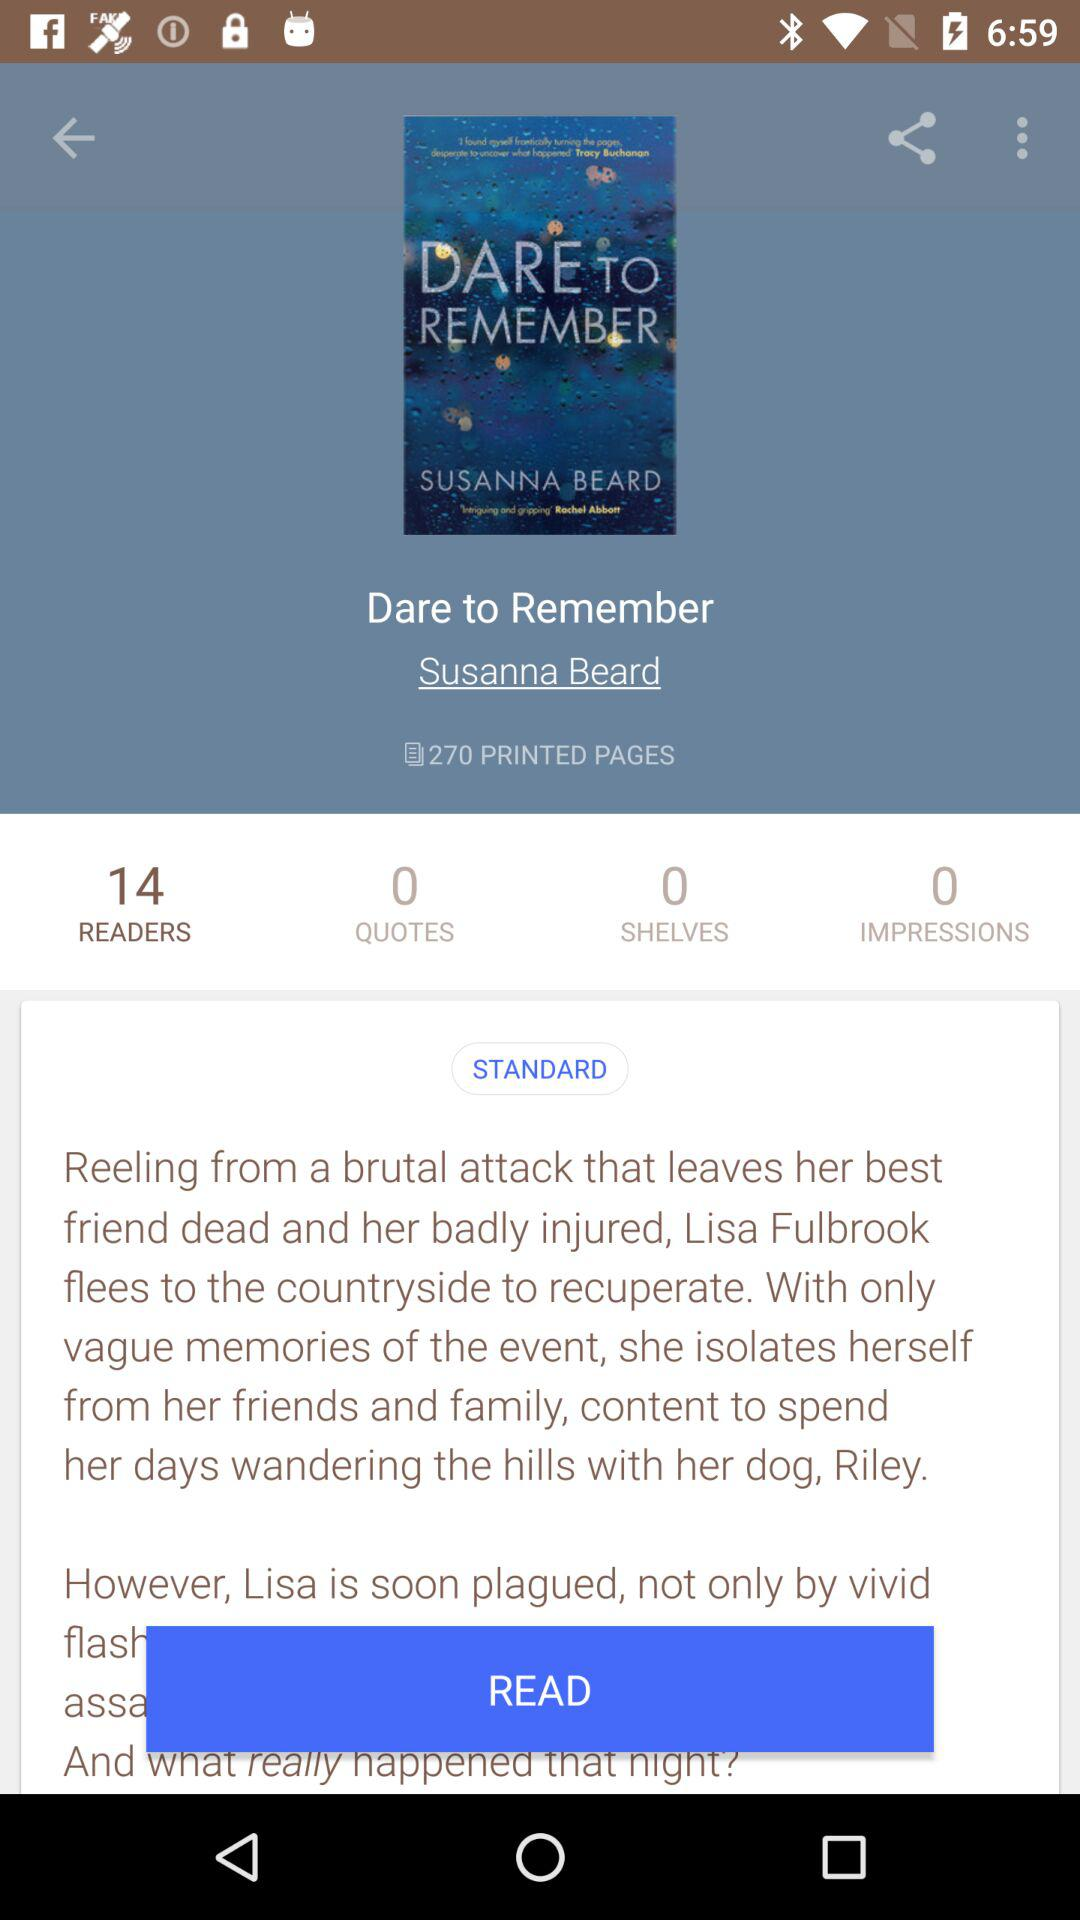What's the total number of readers? The total number of readers is 14. 